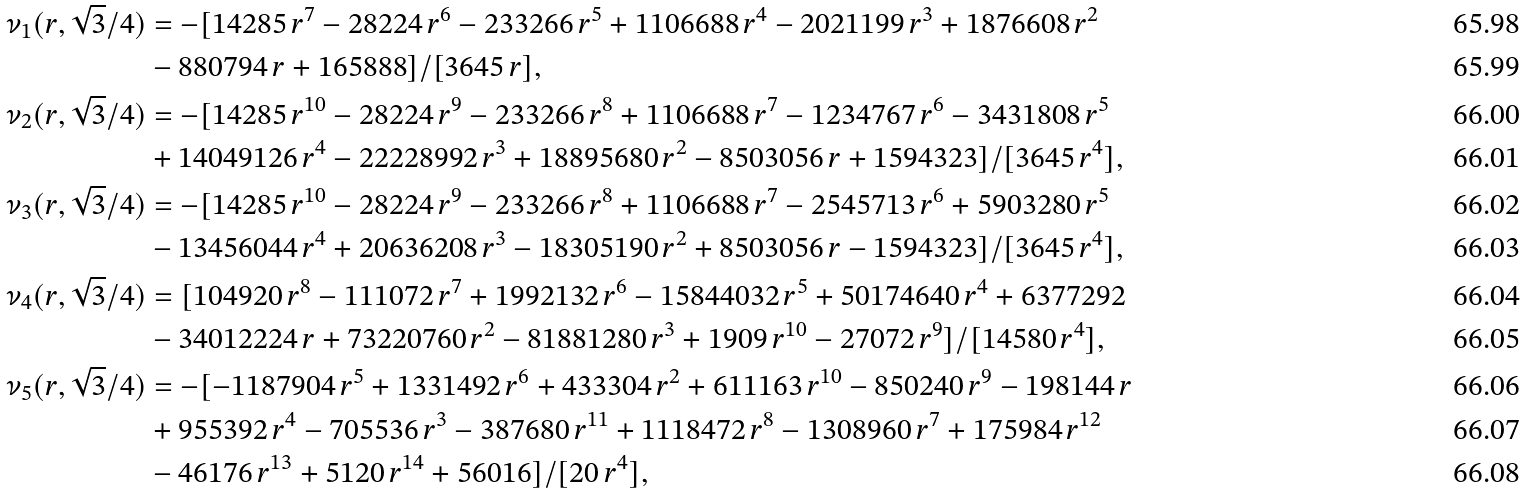Convert formula to latex. <formula><loc_0><loc_0><loc_500><loc_500>\nu _ { 1 } ( r , \sqrt { 3 } / 4 ) & = - [ 1 4 2 8 5 \, r ^ { 7 } - 2 8 2 2 4 \, r ^ { 6 } - 2 3 3 2 6 6 \, r ^ { 5 } + 1 1 0 6 6 8 8 \, r ^ { 4 } - 2 0 2 1 1 9 9 \, r ^ { 3 } + 1 8 7 6 6 0 8 \, r ^ { 2 } \\ & - 8 8 0 7 9 4 \, r + 1 6 5 8 8 8 ] / [ 3 6 4 5 \, r ] , \\ \nu _ { 2 } ( r , \sqrt { 3 } / 4 ) & = - [ 1 4 2 8 5 \, r ^ { 1 0 } - 2 8 2 2 4 \, r ^ { 9 } - 2 3 3 2 6 6 \, r ^ { 8 } + 1 1 0 6 6 8 8 \, r ^ { 7 } - 1 2 3 4 7 6 7 \, r ^ { 6 } - 3 4 3 1 8 0 8 \, r ^ { 5 } \\ & + 1 4 0 4 9 1 2 6 \, r ^ { 4 } - 2 2 2 2 8 9 9 2 \, r ^ { 3 } + 1 8 8 9 5 6 8 0 \, r ^ { 2 } - 8 5 0 3 0 5 6 \, r + 1 5 9 4 3 2 3 ] / [ 3 6 4 5 \, r ^ { 4 } ] , \\ \nu _ { 3 } ( r , \sqrt { 3 } / 4 ) & = - [ 1 4 2 8 5 \, r ^ { 1 0 } - 2 8 2 2 4 \, r ^ { 9 } - 2 3 3 2 6 6 \, r ^ { 8 } + 1 1 0 6 6 8 8 \, r ^ { 7 } - 2 5 4 5 7 1 3 \, r ^ { 6 } + 5 9 0 3 2 8 0 \, r ^ { 5 } \\ & - 1 3 4 5 6 0 4 4 \, r ^ { 4 } + 2 0 6 3 6 2 0 8 \, r ^ { 3 } - 1 8 3 0 5 1 9 0 \, r ^ { 2 } + 8 5 0 3 0 5 6 \, r - 1 5 9 4 3 2 3 ] / [ 3 6 4 5 \, r ^ { 4 } ] , \\ \nu _ { 4 } ( r , \sqrt { 3 } / 4 ) & = [ 1 0 4 9 2 0 \, r ^ { 8 } - 1 1 1 0 7 2 \, r ^ { 7 } + 1 9 9 2 1 3 2 \, r ^ { 6 } - 1 5 8 4 4 0 3 2 \, r ^ { 5 } + 5 0 1 7 4 6 4 0 \, r ^ { 4 } + 6 3 7 7 2 9 2 \\ & - 3 4 0 1 2 2 2 4 \, r + 7 3 2 2 0 7 6 0 \, r ^ { 2 } - 8 1 8 8 1 2 8 0 \, r ^ { 3 } + 1 9 0 9 \, r ^ { 1 0 } - 2 7 0 7 2 \, r ^ { 9 } ] / [ 1 4 5 8 0 \, r ^ { 4 } ] , \\ \nu _ { 5 } ( r , \sqrt { 3 } / 4 ) & = - [ - 1 1 8 7 9 0 4 \, r ^ { 5 } + 1 3 3 1 4 9 2 \, r ^ { 6 } + 4 3 3 3 0 4 \, r ^ { 2 } + 6 1 1 1 6 3 \, r ^ { 1 0 } - 8 5 0 2 4 0 \, r ^ { 9 } - 1 9 8 1 4 4 \, r \\ & + 9 5 5 3 9 2 \, r ^ { 4 } - 7 0 5 5 3 6 \, r ^ { 3 } - 3 8 7 6 8 0 \, r ^ { 1 1 } + 1 1 1 8 4 7 2 \, r ^ { 8 } - 1 3 0 8 9 6 0 \, r ^ { 7 } + 1 7 5 9 8 4 \, r ^ { 1 2 } \\ & - 4 6 1 7 6 \, r ^ { 1 3 } + 5 1 2 0 \, r ^ { 1 4 } + 5 6 0 1 6 ] / [ 2 0 \, r ^ { 4 } ] ,</formula> 